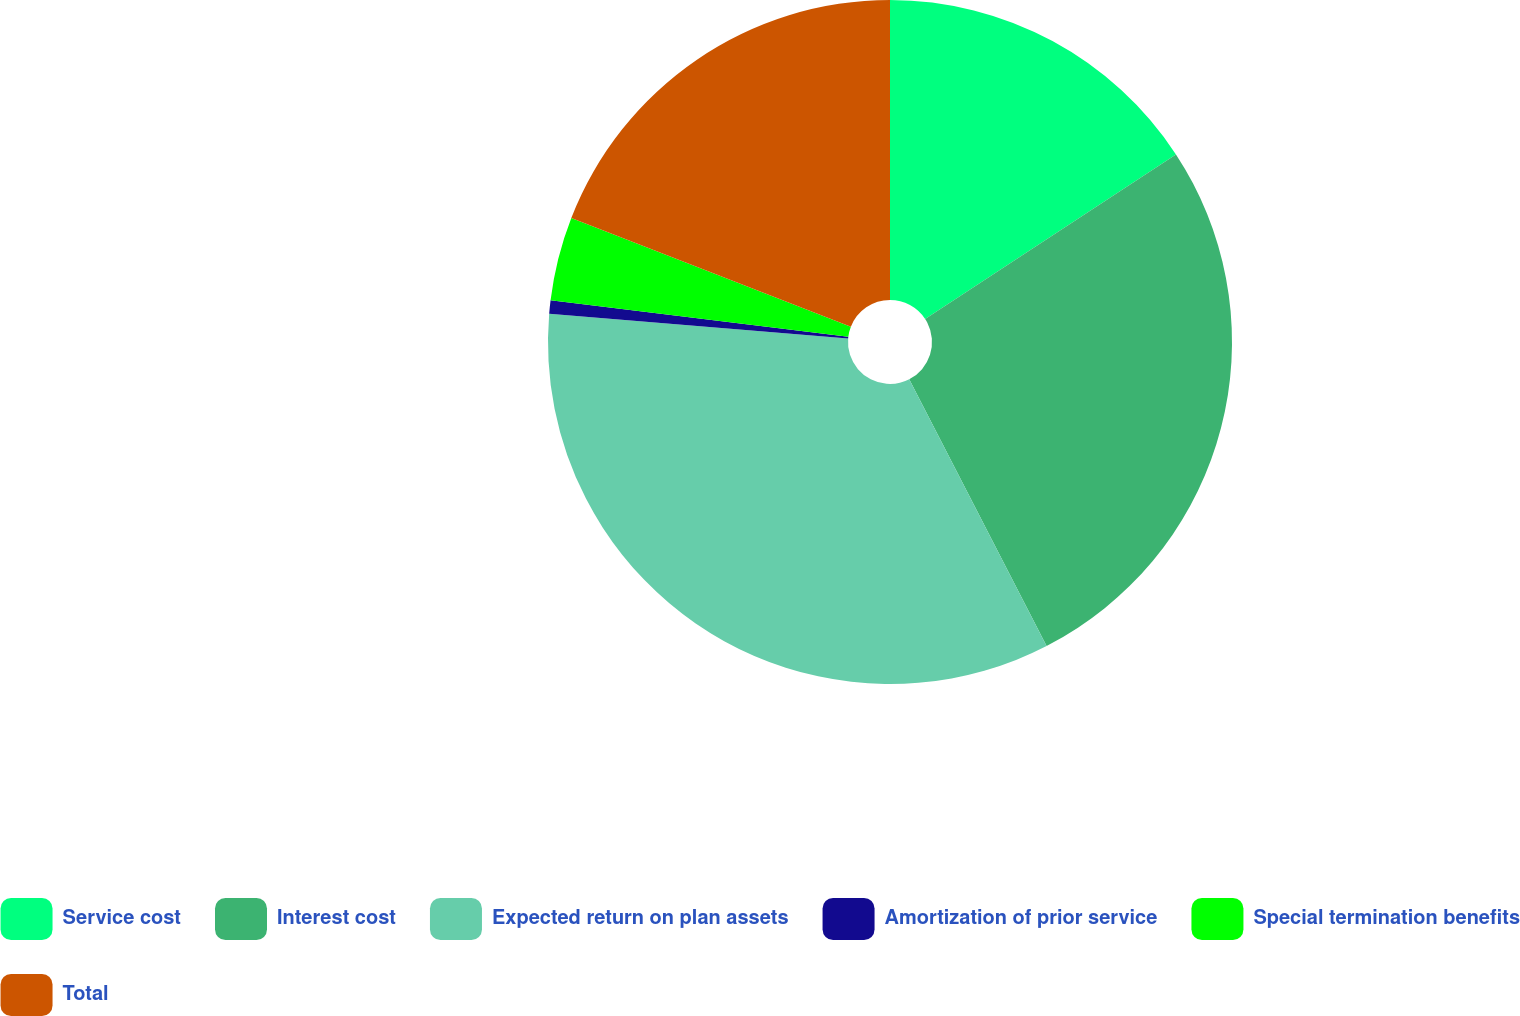<chart> <loc_0><loc_0><loc_500><loc_500><pie_chart><fcel>Service cost<fcel>Interest cost<fcel>Expected return on plan assets<fcel>Amortization of prior service<fcel>Special termination benefits<fcel>Total<nl><fcel>15.76%<fcel>26.67%<fcel>33.89%<fcel>0.63%<fcel>3.96%<fcel>19.09%<nl></chart> 